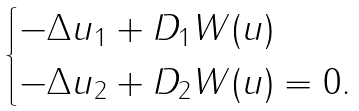<formula> <loc_0><loc_0><loc_500><loc_500>\begin{cases} - \Delta { u } _ { 1 } + D _ { 1 } W ( { u } ) \\ - \Delta { u } _ { 2 } + D _ { 2 } W ( { u } ) = 0 . \end{cases}</formula> 